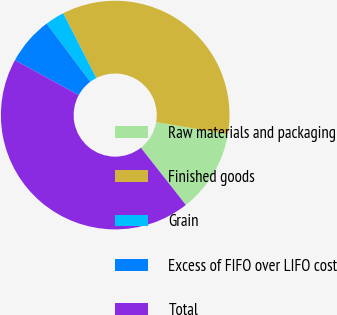<chart> <loc_0><loc_0><loc_500><loc_500><pie_chart><fcel>Raw materials and packaging<fcel>Finished goods<fcel>Grain<fcel>Excess of FIFO over LIFO cost<fcel>Total<nl><fcel>11.71%<fcel>35.21%<fcel>2.71%<fcel>6.8%<fcel>43.57%<nl></chart> 